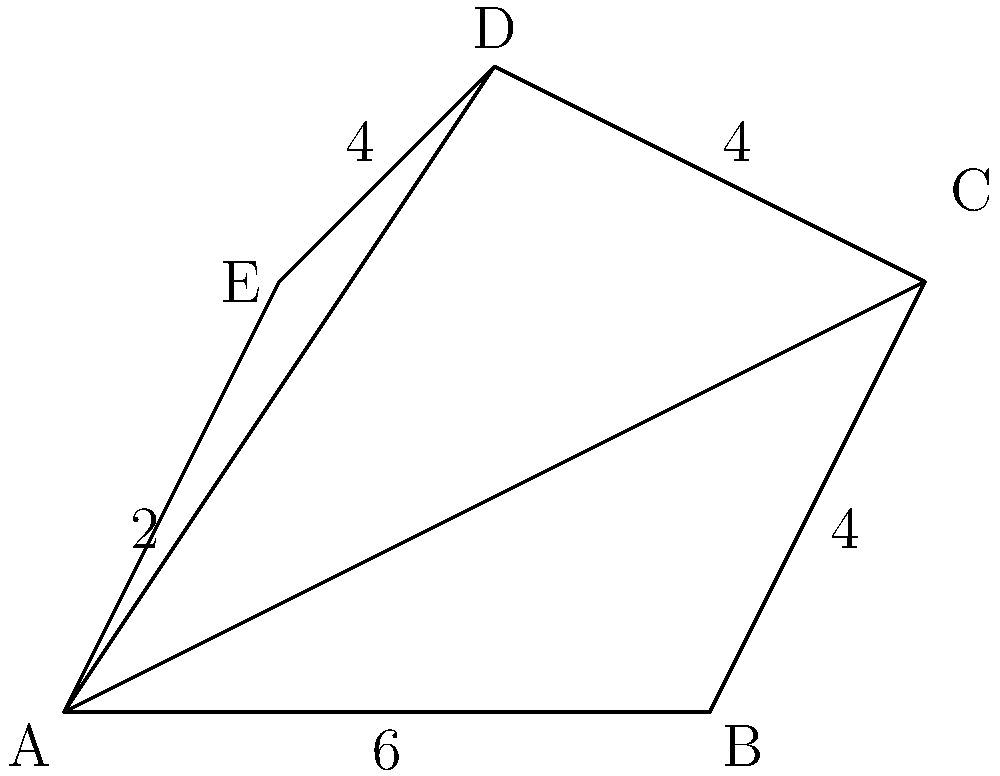In your latest historical novel, you're describing a peculiar piece of land that a character inherits. The land is shaped like an irregular pentagon ABCDE, as shown in the figure. The lengths of the sides are: AB = 6 units, BC = 4 units, CD = 4 units, DE = 4 units, and EA = 2 units. To determine the value of the land, you need to calculate its area. How would you find the area of this irregularly shaped polygon by dividing it into triangles? To find the area of the irregular pentagon ABCDE, we can divide it into three triangles: ABC, ACD, and ADE. We'll calculate the area of each triangle and then sum them up.

1. For triangle ABC:
   Base = AB = 6 units
   Height = 4 units (given by the perpendicular distance from C to AB)
   Area of ABC = $\frac{1}{2} \times 6 \times 4 = 12$ square units

2. For triangle ACD:
   We need to find its base and height. 
   Base = AD (which we can calculate using the Pythagorean theorem)
   $AD^2 = 4^2 + 6^2 = 16 + 36 = 52$
   $AD = \sqrt{52} \approx 7.21$ units
   Height = perpendicular distance from C to AD
   We can find this using the area of triangle ACD: $\frac{1}{2} \times 7.21 \times h = 12$
   $h = \frac{24}{7.21} \approx 3.33$ units
   Area of ACD = $12$ square units

3. For triangle ADE:
   Base = DE = 4 units
   Height = 2 units (given by the perpendicular distance from A to DE)
   Area of ADE = $\frac{1}{2} \times 4 \times 2 = 4$ square units

4. Total area:
   Area of ABCDE = Area of ABC + Area of ACD + Area of ADE
                 = 12 + 12 + 4 = 28 square units
Answer: 28 square units 